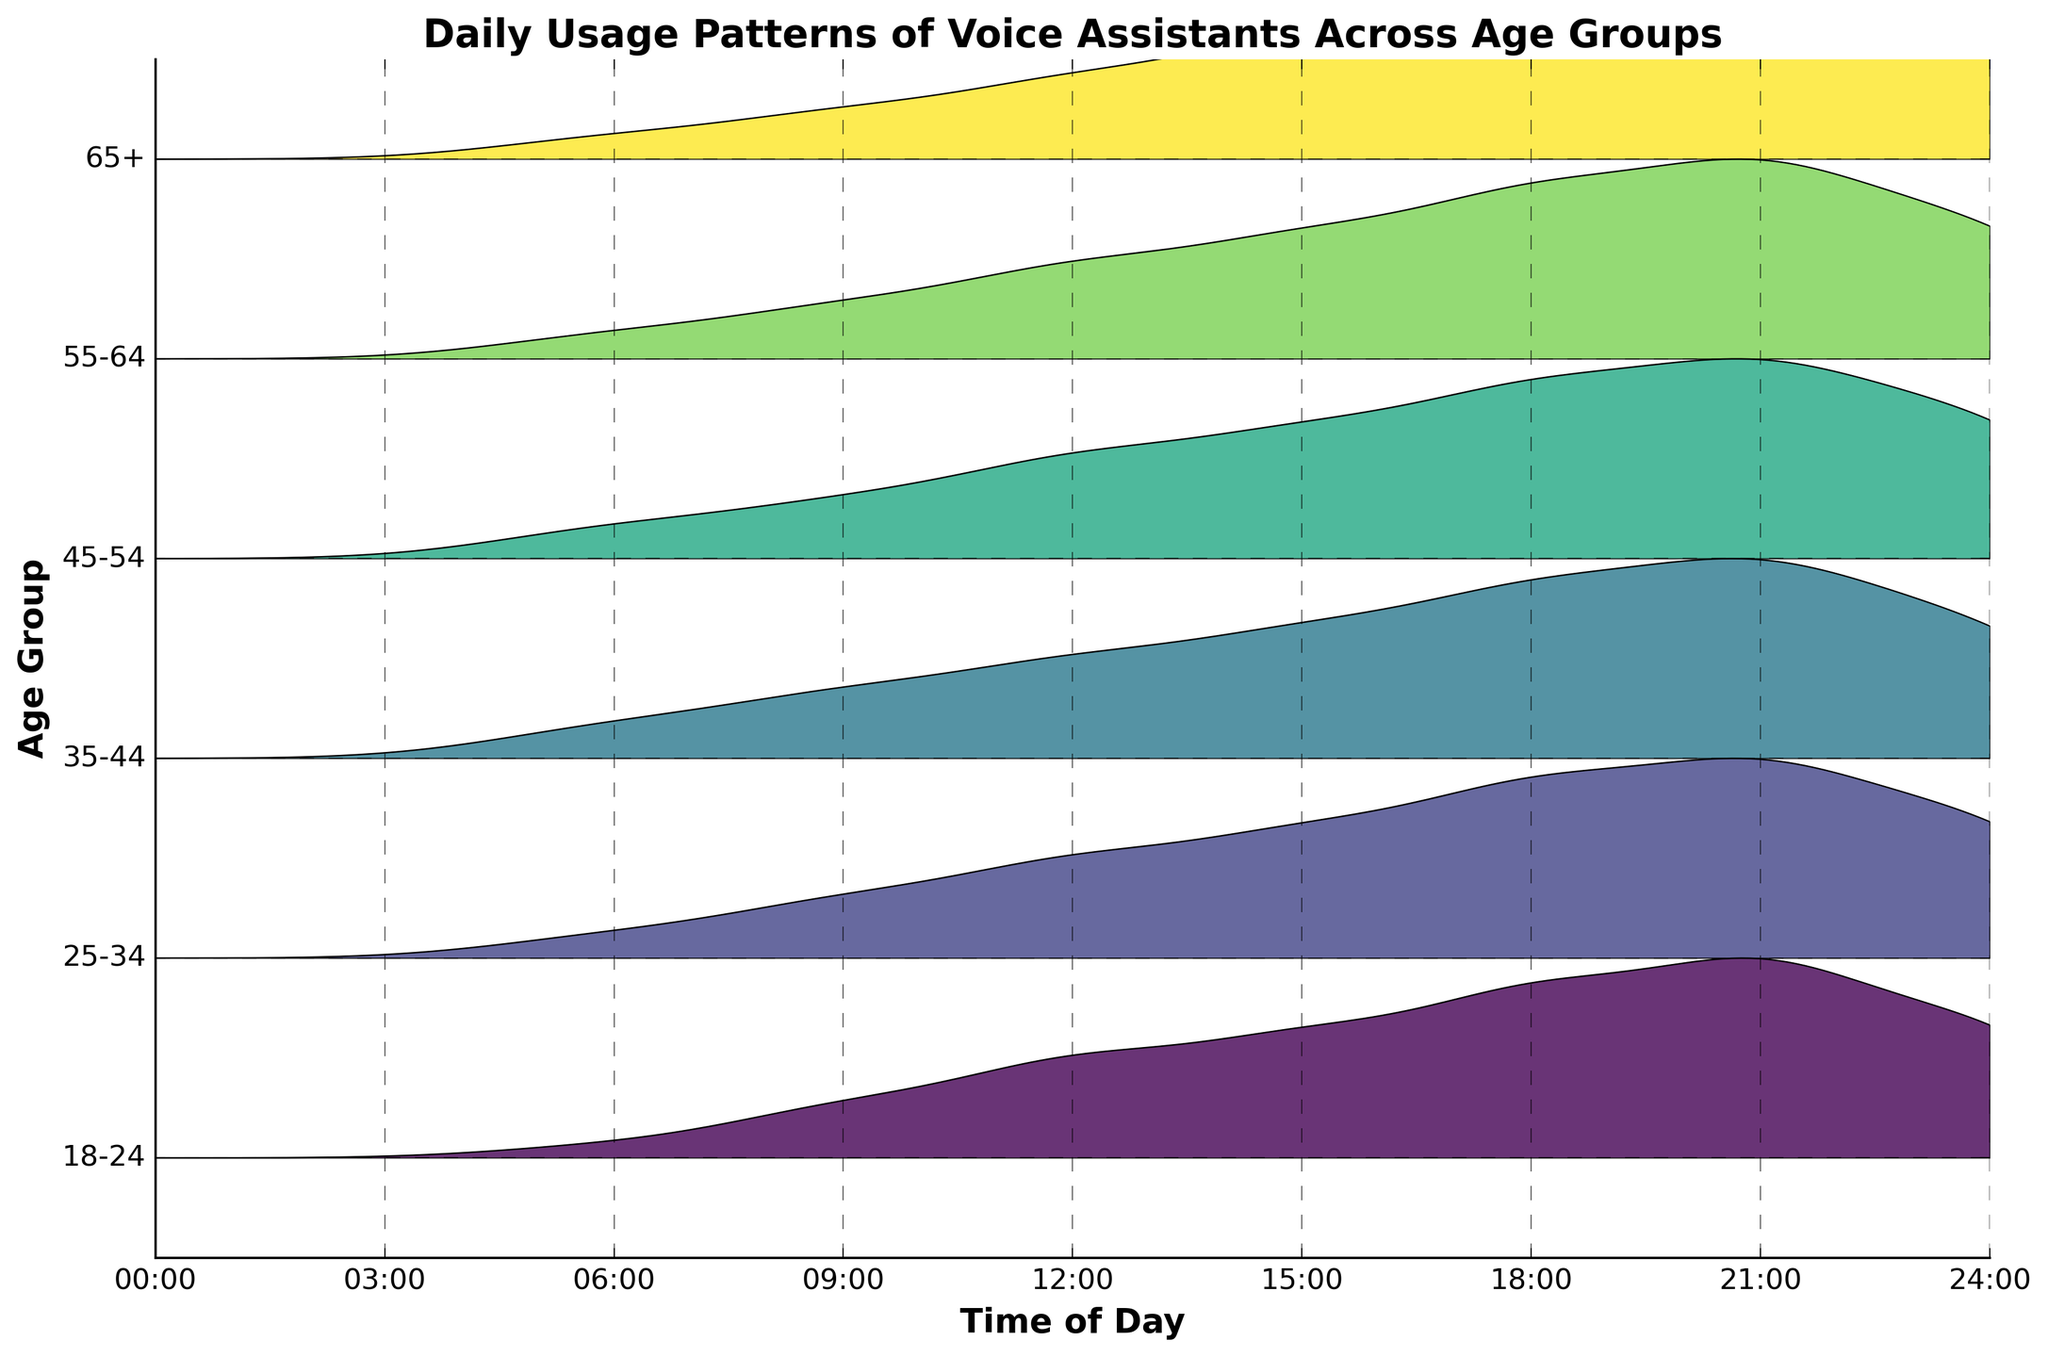When is the peak usage for the 25-34 age group? By looking at the ridgeline for the 25-34 age group, we can see that the height of the curve is highest around 9 PM, indicating peak usage at that time.
Answer: Around 9 PM Which age group shows the highest overall usage of voice assistants throughout the day? By comparing the ridgeline heights across all age groups, the 35-44 age group consistently has the highest heights, indicating the highest overall usage.
Answer: 35-44 At which time of day does the 55-64 age group start to show significant usage? The ridgeline for the 55-64 age group begins to rise noticeably at around 6 PM, indicating significant usage starting then.
Answer: Around 6 PM Compare the usage frequency at noon (12 PM) between the 18-24 and 65+ age groups. At noon, the ridgeline for the 18-24 age group is higher than that of the 65+ age group, indicating higher usage in the younger group at this time.
Answer: 18-24 has higher usage Which age group has the least variation in usage frequency throughout the day? The 65+ age group shows the least variation in ridgeline heights, indicating more consistent usage frequencies compared to other age groups.
Answer: 65+ How does the usage pattern of the 45-54 age group at 6 PM compare to other groups? At 6 PM, the ridgeline for the 45-54 age group is higher than most other age groups, except the 35-44 age group, indicating relatively high usage.
Answer: Higher than most, except 35-44 What can you infer about the general trend in usage frequency as the age groups increase? There appears to be a general trend where younger age groups use voice assistants more frequently and have higher peaks, while older age groups show less frequent usage and lower peaks.
Answer: Younger groups use more Which age group shows a significant decrease in usage after 9 PM? The 18-24 age group's ridgeline drops significantly after 9 PM, indicating a decrease in usage.
Answer: 18-24 Are there any age groups with a second peak in usage frequency? If so, which one and when? The 35-44 age group shows a second, smaller peak around midnight in addition to its main peak at 9 PM.
Answer: 35-44 around midnight 